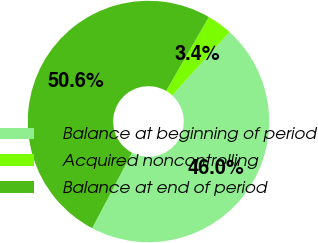Convert chart to OTSL. <chart><loc_0><loc_0><loc_500><loc_500><pie_chart><fcel>Balance at beginning of period<fcel>Acquired noncontrolling<fcel>Balance at end of period<nl><fcel>46.01%<fcel>3.38%<fcel>50.61%<nl></chart> 